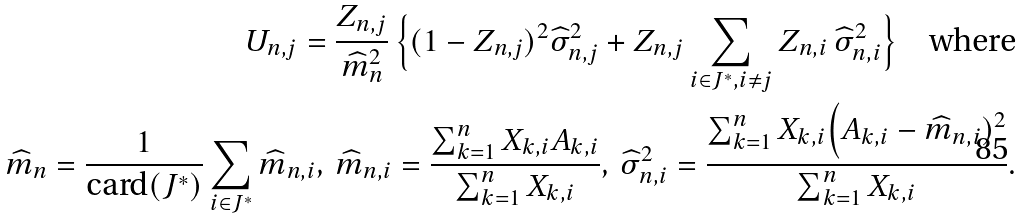Convert formula to latex. <formula><loc_0><loc_0><loc_500><loc_500>U _ { n , j } = \frac { Z _ { n , j } } { \widehat { m } _ { n } ^ { 2 } } \, \Big \{ ( 1 - Z _ { n , j } ) ^ { 2 } \widehat { \sigma } _ { n , j } ^ { 2 } + Z _ { n , j } \sum _ { i \in J ^ { * } , i \neq j } Z _ { n , i } \, \widehat { \sigma } _ { n , i } ^ { 2 } \Big \} \quad \text {where} \\ \widehat { m } _ { n } = \frac { 1 } { \text {card} ( J ^ { * } ) } \sum _ { i \in J ^ { * } } \widehat { m } _ { n , i } , \, \widehat { m } _ { n , i } = \frac { \sum _ { k = 1 } ^ { n } X _ { k , i } A _ { k , i } } { \sum _ { k = 1 } ^ { n } X _ { k , i } } , \, \widehat { \sigma } _ { n , i } ^ { 2 } = \frac { \sum _ { k = 1 } ^ { n } X _ { k , i } \Big ( A _ { k , i } - \widehat { m } _ { n , i } ) ^ { 2 } } { \sum _ { k = 1 } ^ { n } X _ { k , i } } .</formula> 